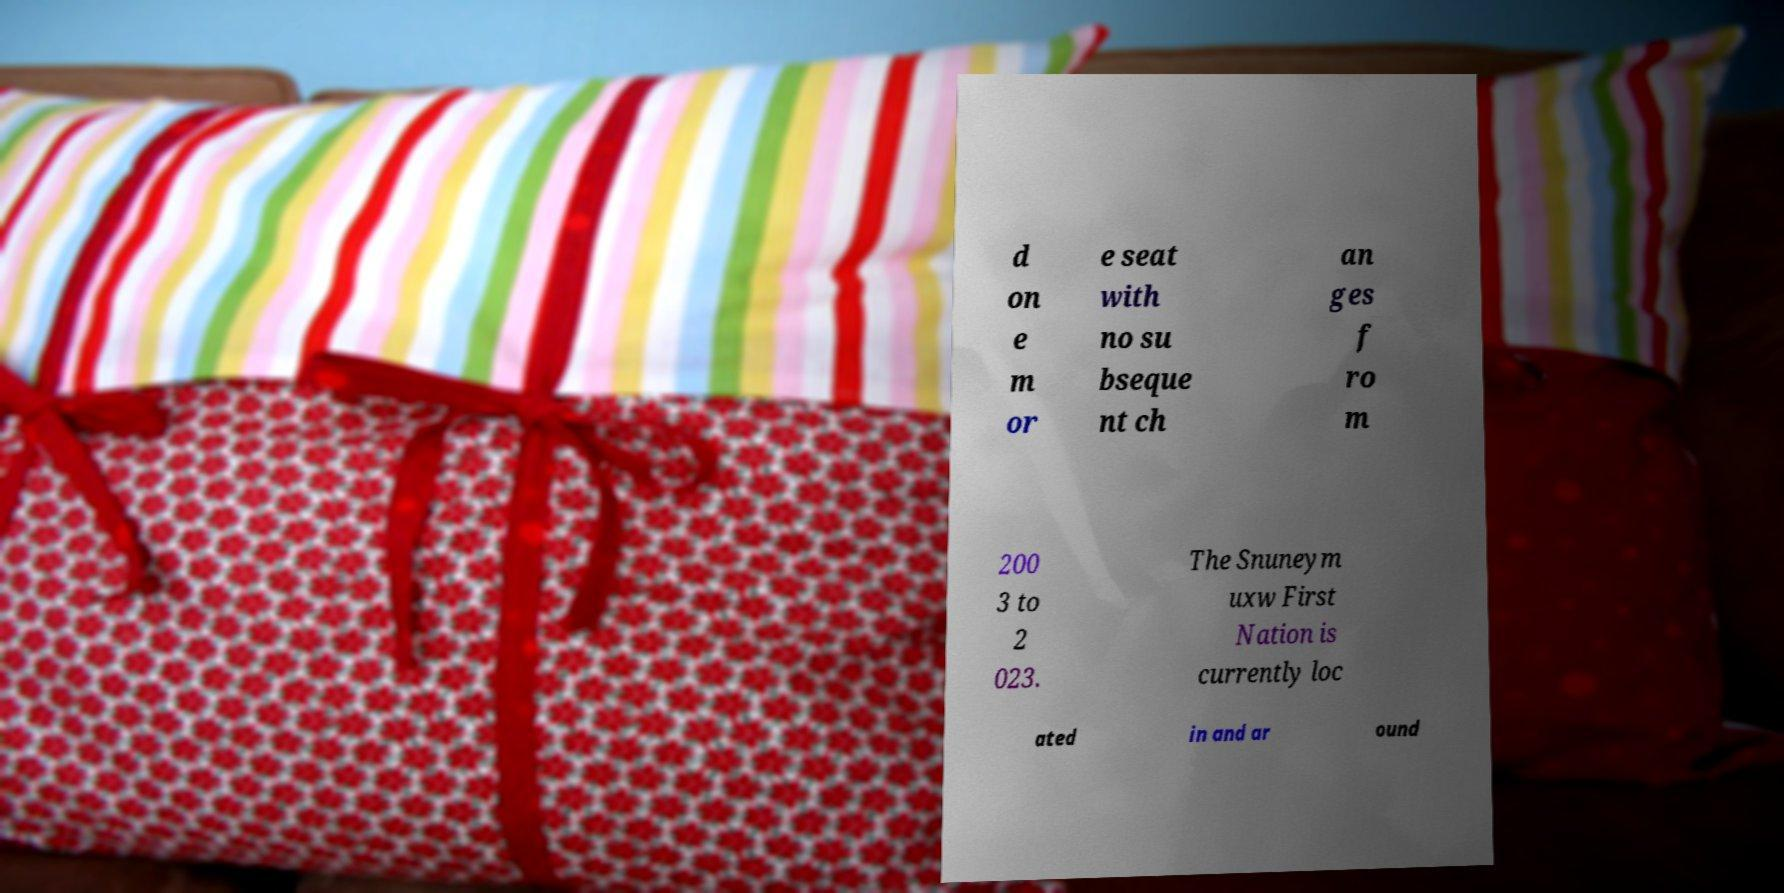Can you read and provide the text displayed in the image?This photo seems to have some interesting text. Can you extract and type it out for me? d on e m or e seat with no su bseque nt ch an ges f ro m 200 3 to 2 023. The Snuneym uxw First Nation is currently loc ated in and ar ound 